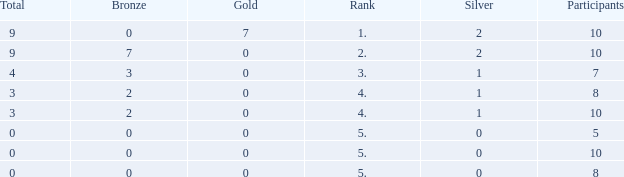What's the total Rank that has a Gold that's smaller than 0? None. 